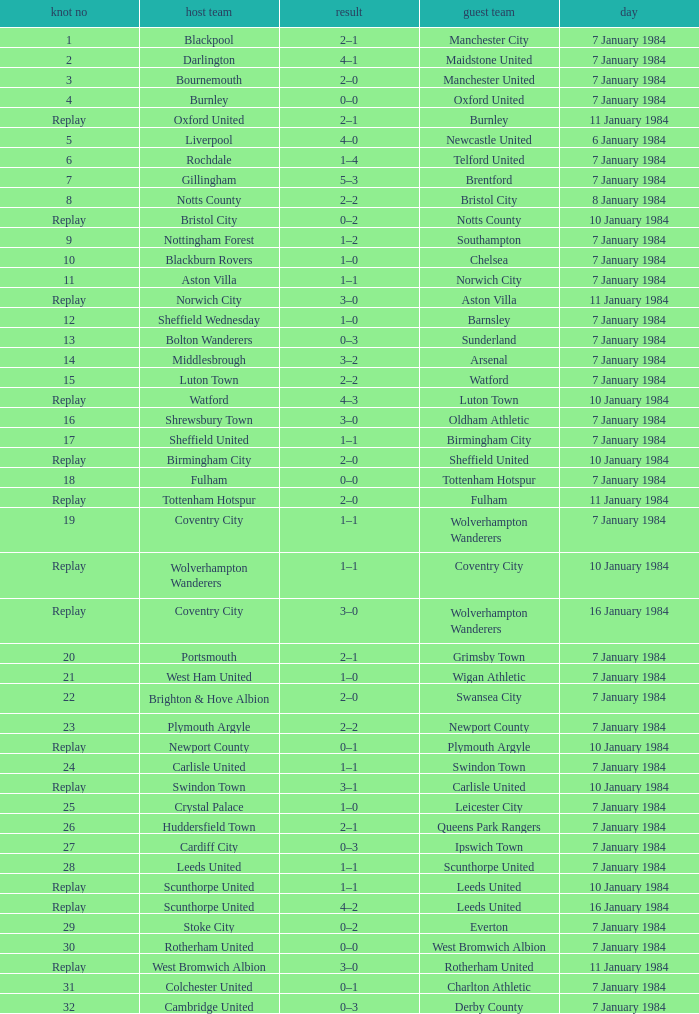Who was the away team with a tie of 14? Arsenal. Can you parse all the data within this table? {'header': ['knot no', 'host team', 'result', 'guest team', 'day'], 'rows': [['1', 'Blackpool', '2–1', 'Manchester City', '7 January 1984'], ['2', 'Darlington', '4–1', 'Maidstone United', '7 January 1984'], ['3', 'Bournemouth', '2–0', 'Manchester United', '7 January 1984'], ['4', 'Burnley', '0–0', 'Oxford United', '7 January 1984'], ['Replay', 'Oxford United', '2–1', 'Burnley', '11 January 1984'], ['5', 'Liverpool', '4–0', 'Newcastle United', '6 January 1984'], ['6', 'Rochdale', '1–4', 'Telford United', '7 January 1984'], ['7', 'Gillingham', '5–3', 'Brentford', '7 January 1984'], ['8', 'Notts County', '2–2', 'Bristol City', '8 January 1984'], ['Replay', 'Bristol City', '0–2', 'Notts County', '10 January 1984'], ['9', 'Nottingham Forest', '1–2', 'Southampton', '7 January 1984'], ['10', 'Blackburn Rovers', '1–0', 'Chelsea', '7 January 1984'], ['11', 'Aston Villa', '1–1', 'Norwich City', '7 January 1984'], ['Replay', 'Norwich City', '3–0', 'Aston Villa', '11 January 1984'], ['12', 'Sheffield Wednesday', '1–0', 'Barnsley', '7 January 1984'], ['13', 'Bolton Wanderers', '0–3', 'Sunderland', '7 January 1984'], ['14', 'Middlesbrough', '3–2', 'Arsenal', '7 January 1984'], ['15', 'Luton Town', '2–2', 'Watford', '7 January 1984'], ['Replay', 'Watford', '4–3', 'Luton Town', '10 January 1984'], ['16', 'Shrewsbury Town', '3–0', 'Oldham Athletic', '7 January 1984'], ['17', 'Sheffield United', '1–1', 'Birmingham City', '7 January 1984'], ['Replay', 'Birmingham City', '2–0', 'Sheffield United', '10 January 1984'], ['18', 'Fulham', '0–0', 'Tottenham Hotspur', '7 January 1984'], ['Replay', 'Tottenham Hotspur', '2–0', 'Fulham', '11 January 1984'], ['19', 'Coventry City', '1–1', 'Wolverhampton Wanderers', '7 January 1984'], ['Replay', 'Wolverhampton Wanderers', '1–1', 'Coventry City', '10 January 1984'], ['Replay', 'Coventry City', '3–0', 'Wolverhampton Wanderers', '16 January 1984'], ['20', 'Portsmouth', '2–1', 'Grimsby Town', '7 January 1984'], ['21', 'West Ham United', '1–0', 'Wigan Athletic', '7 January 1984'], ['22', 'Brighton & Hove Albion', '2–0', 'Swansea City', '7 January 1984'], ['23', 'Plymouth Argyle', '2–2', 'Newport County', '7 January 1984'], ['Replay', 'Newport County', '0–1', 'Plymouth Argyle', '10 January 1984'], ['24', 'Carlisle United', '1–1', 'Swindon Town', '7 January 1984'], ['Replay', 'Swindon Town', '3–1', 'Carlisle United', '10 January 1984'], ['25', 'Crystal Palace', '1–0', 'Leicester City', '7 January 1984'], ['26', 'Huddersfield Town', '2–1', 'Queens Park Rangers', '7 January 1984'], ['27', 'Cardiff City', '0–3', 'Ipswich Town', '7 January 1984'], ['28', 'Leeds United', '1–1', 'Scunthorpe United', '7 January 1984'], ['Replay', 'Scunthorpe United', '1–1', 'Leeds United', '10 January 1984'], ['Replay', 'Scunthorpe United', '4–2', 'Leeds United', '16 January 1984'], ['29', 'Stoke City', '0–2', 'Everton', '7 January 1984'], ['30', 'Rotherham United', '0–0', 'West Bromwich Albion', '7 January 1984'], ['Replay', 'West Bromwich Albion', '3–0', 'Rotherham United', '11 January 1984'], ['31', 'Colchester United', '0–1', 'Charlton Athletic', '7 January 1984'], ['32', 'Cambridge United', '0–3', 'Derby County', '7 January 1984']]} 